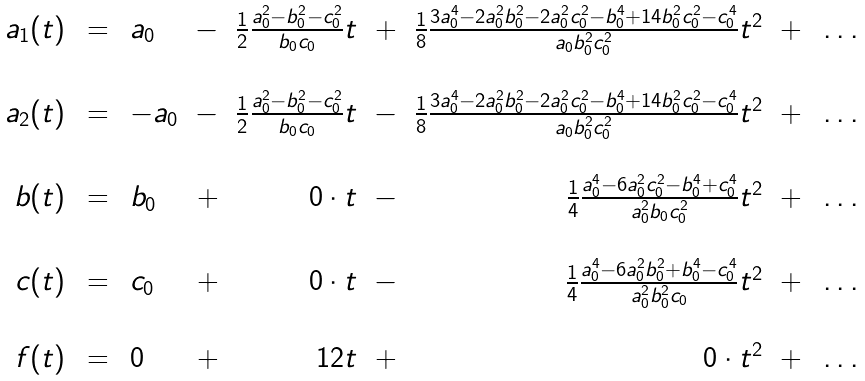Convert formula to latex. <formula><loc_0><loc_0><loc_500><loc_500>\begin{array} { r c l r r r r r r l } a _ { 1 } ( t ) \, & = \, & a _ { 0 } & - & \frac { 1 } { 2 } \frac { a _ { 0 } ^ { 2 } - b _ { 0 } ^ { 2 } - c _ { 0 } ^ { 2 } } { b _ { 0 } c _ { 0 } } t & + & \frac { 1 } { 8 } \frac { 3 a _ { 0 } ^ { 4 } - 2 a _ { 0 } ^ { 2 } b _ { 0 } ^ { 2 } - 2 a _ { 0 } ^ { 2 } c _ { 0 } ^ { 2 } - b _ { 0 } ^ { 4 } + 1 4 b _ { 0 } ^ { 2 } c _ { 0 } ^ { 2 } - c _ { 0 } ^ { 4 } } { a _ { 0 } b _ { 0 } ^ { 2 } c _ { 0 } ^ { 2 } } t ^ { 2 } & + \, & \dots \\ & & & & & & & & \\ a _ { 2 } ( t ) \, & = \, & - a _ { 0 } & - & \frac { 1 } { 2 } \frac { a _ { 0 } ^ { 2 } - b _ { 0 } ^ { 2 } - c _ { 0 } ^ { 2 } } { b _ { 0 } c _ { 0 } } t & - & \frac { 1 } { 8 } \frac { 3 a _ { 0 } ^ { 4 } - 2 a _ { 0 } ^ { 2 } b _ { 0 } ^ { 2 } - 2 a _ { 0 } ^ { 2 } c _ { 0 } ^ { 2 } - b _ { 0 } ^ { 4 } + 1 4 b _ { 0 } ^ { 2 } c _ { 0 } ^ { 2 } - c _ { 0 } ^ { 4 } } { a _ { 0 } b _ { 0 } ^ { 2 } c _ { 0 } ^ { 2 } } t ^ { 2 } & + \, & \dots \\ & & & & & & & & \\ b ( t ) \, & = \, & b _ { 0 } & + & 0 \cdot t & - & \frac { 1 } { 4 } \frac { a _ { 0 } ^ { 4 } - 6 a _ { 0 } ^ { 2 } c _ { 0 } ^ { 2 } - b _ { 0 } ^ { 4 } + c _ { 0 } ^ { 4 } } { a _ { 0 } ^ { 2 } b _ { 0 } c _ { 0 } ^ { 2 } } t ^ { 2 } & + \, & \dots \\ & & & & & & & & \\ c ( t ) \, & = \, & c _ { 0 } & + & 0 \cdot t & - & \frac { 1 } { 4 } \frac { a _ { 0 } ^ { 4 } - 6 a _ { 0 } ^ { 2 } b _ { 0 } ^ { 2 } + b _ { 0 } ^ { 4 } - c _ { 0 } ^ { 4 } } { a _ { 0 } ^ { 2 } b _ { 0 } ^ { 2 } c _ { 0 } } t ^ { 2 } & + \, & \dots \\ & & & & & & & & \\ f ( t ) \, & = \, & 0 & + & 1 2 t & + & 0 \cdot t ^ { 2 } & + \, & \dots \\ \end{array}</formula> 